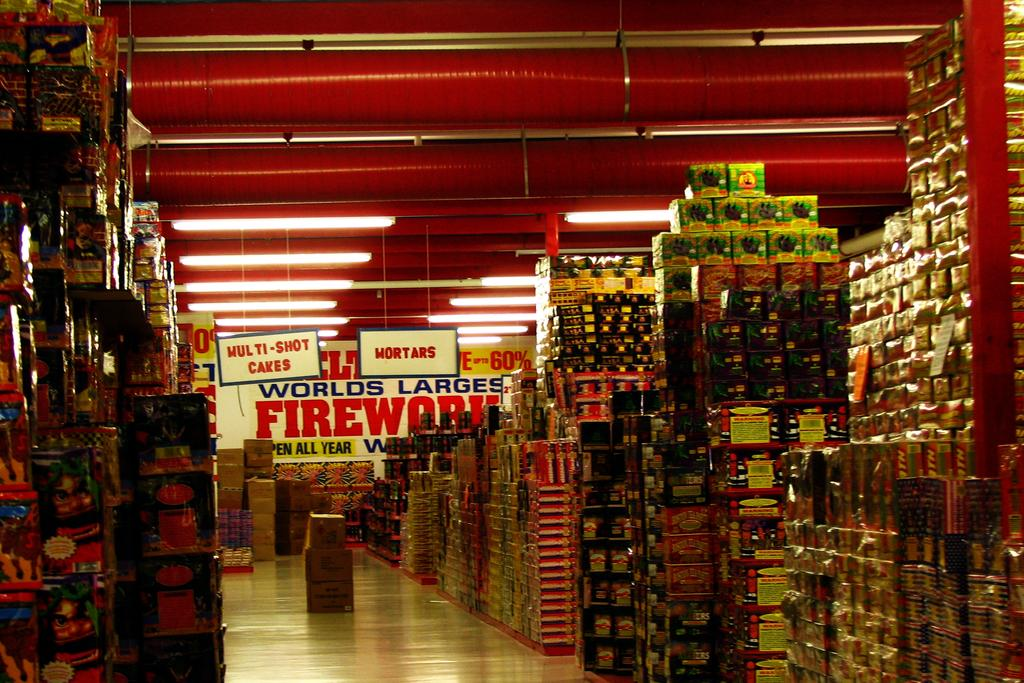<image>
Share a concise interpretation of the image provided. A store's sales floor is full of fireworks of various kinds with a sign in the background that reads "World's Largest Firework". 